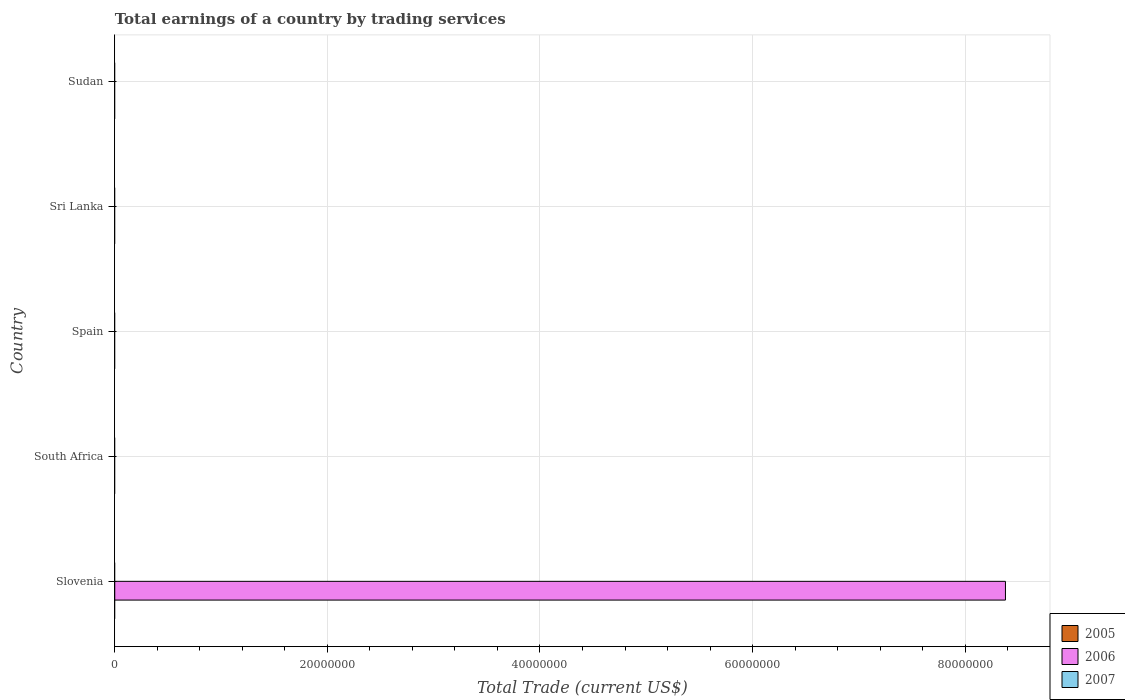How many different coloured bars are there?
Keep it short and to the point. 1. Are the number of bars per tick equal to the number of legend labels?
Make the answer very short. No. Are the number of bars on each tick of the Y-axis equal?
Give a very brief answer. No. How many bars are there on the 5th tick from the top?
Offer a very short reply. 1. How many bars are there on the 2nd tick from the bottom?
Your answer should be compact. 0. What is the label of the 4th group of bars from the top?
Give a very brief answer. South Africa. What is the total earnings in 2007 in Spain?
Your response must be concise. 0. Across all countries, what is the maximum total earnings in 2006?
Give a very brief answer. 8.38e+07. In which country was the total earnings in 2006 maximum?
Your response must be concise. Slovenia. What is the total total earnings in 2006 in the graph?
Offer a terse response. 8.38e+07. What is the average total earnings in 2007 per country?
Keep it short and to the point. 0. What is the difference between the highest and the lowest total earnings in 2006?
Ensure brevity in your answer.  8.38e+07. How many bars are there?
Make the answer very short. 1. What is the difference between two consecutive major ticks on the X-axis?
Give a very brief answer. 2.00e+07. Does the graph contain any zero values?
Offer a terse response. Yes. Where does the legend appear in the graph?
Provide a short and direct response. Bottom right. What is the title of the graph?
Ensure brevity in your answer.  Total earnings of a country by trading services. Does "1967" appear as one of the legend labels in the graph?
Ensure brevity in your answer.  No. What is the label or title of the X-axis?
Ensure brevity in your answer.  Total Trade (current US$). What is the Total Trade (current US$) in 2006 in Slovenia?
Offer a very short reply. 8.38e+07. What is the Total Trade (current US$) of 2007 in Slovenia?
Your response must be concise. 0. What is the Total Trade (current US$) in 2006 in South Africa?
Your response must be concise. 0. What is the Total Trade (current US$) in 2007 in Spain?
Give a very brief answer. 0. What is the Total Trade (current US$) of 2007 in Sri Lanka?
Provide a short and direct response. 0. What is the Total Trade (current US$) in 2007 in Sudan?
Give a very brief answer. 0. Across all countries, what is the maximum Total Trade (current US$) of 2006?
Offer a terse response. 8.38e+07. What is the total Total Trade (current US$) of 2005 in the graph?
Give a very brief answer. 0. What is the total Total Trade (current US$) in 2006 in the graph?
Your answer should be very brief. 8.38e+07. What is the average Total Trade (current US$) in 2005 per country?
Make the answer very short. 0. What is the average Total Trade (current US$) in 2006 per country?
Keep it short and to the point. 1.68e+07. What is the difference between the highest and the lowest Total Trade (current US$) in 2006?
Give a very brief answer. 8.38e+07. 